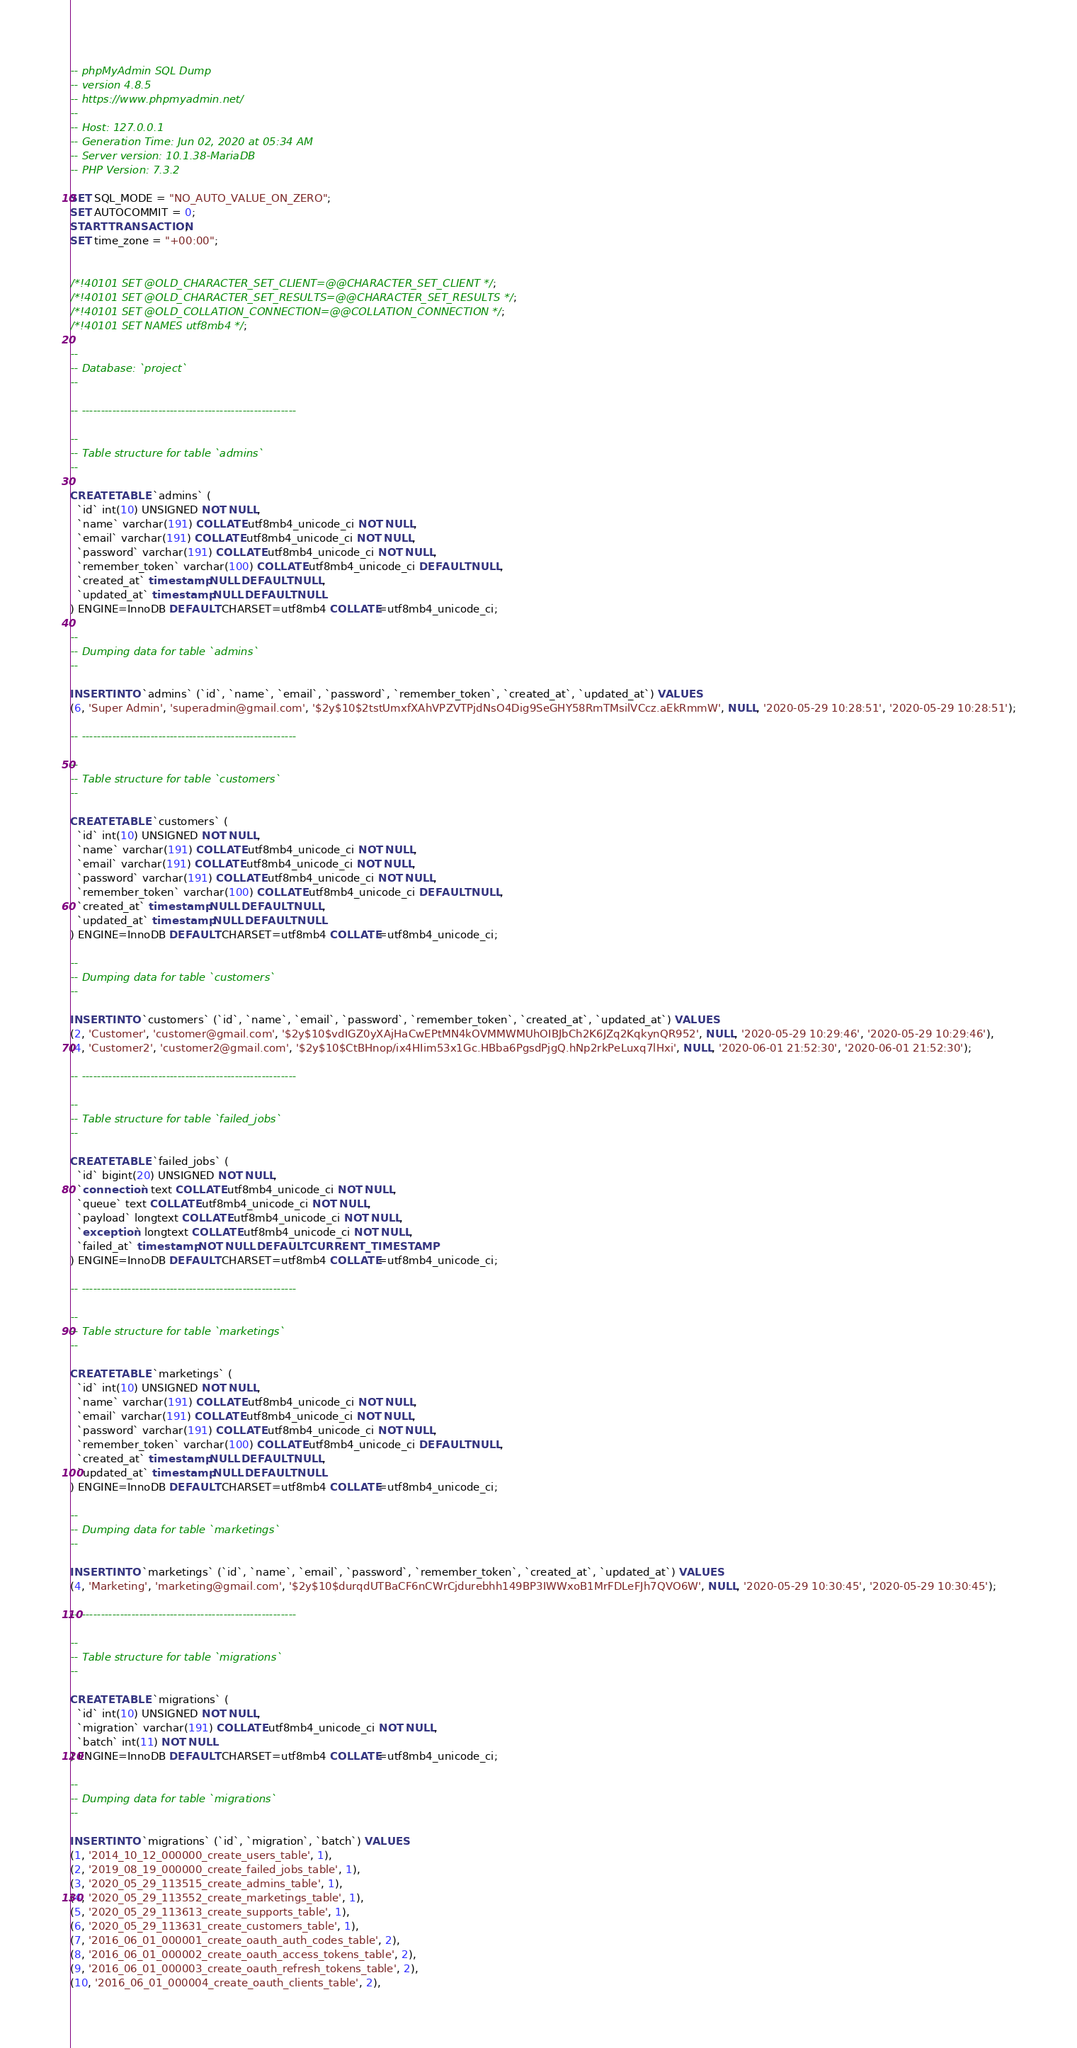<code> <loc_0><loc_0><loc_500><loc_500><_SQL_>-- phpMyAdmin SQL Dump
-- version 4.8.5
-- https://www.phpmyadmin.net/
--
-- Host: 127.0.0.1
-- Generation Time: Jun 02, 2020 at 05:34 AM
-- Server version: 10.1.38-MariaDB
-- PHP Version: 7.3.2

SET SQL_MODE = "NO_AUTO_VALUE_ON_ZERO";
SET AUTOCOMMIT = 0;
START TRANSACTION;
SET time_zone = "+00:00";


/*!40101 SET @OLD_CHARACTER_SET_CLIENT=@@CHARACTER_SET_CLIENT */;
/*!40101 SET @OLD_CHARACTER_SET_RESULTS=@@CHARACTER_SET_RESULTS */;
/*!40101 SET @OLD_COLLATION_CONNECTION=@@COLLATION_CONNECTION */;
/*!40101 SET NAMES utf8mb4 */;

--
-- Database: `project`
--

-- --------------------------------------------------------

--
-- Table structure for table `admins`
--

CREATE TABLE `admins` (
  `id` int(10) UNSIGNED NOT NULL,
  `name` varchar(191) COLLATE utf8mb4_unicode_ci NOT NULL,
  `email` varchar(191) COLLATE utf8mb4_unicode_ci NOT NULL,
  `password` varchar(191) COLLATE utf8mb4_unicode_ci NOT NULL,
  `remember_token` varchar(100) COLLATE utf8mb4_unicode_ci DEFAULT NULL,
  `created_at` timestamp NULL DEFAULT NULL,
  `updated_at` timestamp NULL DEFAULT NULL
) ENGINE=InnoDB DEFAULT CHARSET=utf8mb4 COLLATE=utf8mb4_unicode_ci;

--
-- Dumping data for table `admins`
--

INSERT INTO `admins` (`id`, `name`, `email`, `password`, `remember_token`, `created_at`, `updated_at`) VALUES
(6, 'Super Admin', 'superadmin@gmail.com', '$2y$10$2tstUmxfXAhVPZVTPjdNsO4Dig9SeGHY58RmTMsilVCcz.aEkRmmW', NULL, '2020-05-29 10:28:51', '2020-05-29 10:28:51');

-- --------------------------------------------------------

--
-- Table structure for table `customers`
--

CREATE TABLE `customers` (
  `id` int(10) UNSIGNED NOT NULL,
  `name` varchar(191) COLLATE utf8mb4_unicode_ci NOT NULL,
  `email` varchar(191) COLLATE utf8mb4_unicode_ci NOT NULL,
  `password` varchar(191) COLLATE utf8mb4_unicode_ci NOT NULL,
  `remember_token` varchar(100) COLLATE utf8mb4_unicode_ci DEFAULT NULL,
  `created_at` timestamp NULL DEFAULT NULL,
  `updated_at` timestamp NULL DEFAULT NULL
) ENGINE=InnoDB DEFAULT CHARSET=utf8mb4 COLLATE=utf8mb4_unicode_ci;

--
-- Dumping data for table `customers`
--

INSERT INTO `customers` (`id`, `name`, `email`, `password`, `remember_token`, `created_at`, `updated_at`) VALUES
(2, 'Customer', 'customer@gmail.com', '$2y$10$vdIGZ0yXAjHaCwEPtMN4kOVMMWMUhOIBJbCh2K6JZq2KqkynQR952', NULL, '2020-05-29 10:29:46', '2020-05-29 10:29:46'),
(4, 'Customer2', 'customer2@gmail.com', '$2y$10$CtBHnop/ix4HIim53x1Gc.HBba6PgsdPjgQ.hNp2rkPeLuxq7lHxi', NULL, '2020-06-01 21:52:30', '2020-06-01 21:52:30');

-- --------------------------------------------------------

--
-- Table structure for table `failed_jobs`
--

CREATE TABLE `failed_jobs` (
  `id` bigint(20) UNSIGNED NOT NULL,
  `connection` text COLLATE utf8mb4_unicode_ci NOT NULL,
  `queue` text COLLATE utf8mb4_unicode_ci NOT NULL,
  `payload` longtext COLLATE utf8mb4_unicode_ci NOT NULL,
  `exception` longtext COLLATE utf8mb4_unicode_ci NOT NULL,
  `failed_at` timestamp NOT NULL DEFAULT CURRENT_TIMESTAMP
) ENGINE=InnoDB DEFAULT CHARSET=utf8mb4 COLLATE=utf8mb4_unicode_ci;

-- --------------------------------------------------------

--
-- Table structure for table `marketings`
--

CREATE TABLE `marketings` (
  `id` int(10) UNSIGNED NOT NULL,
  `name` varchar(191) COLLATE utf8mb4_unicode_ci NOT NULL,
  `email` varchar(191) COLLATE utf8mb4_unicode_ci NOT NULL,
  `password` varchar(191) COLLATE utf8mb4_unicode_ci NOT NULL,
  `remember_token` varchar(100) COLLATE utf8mb4_unicode_ci DEFAULT NULL,
  `created_at` timestamp NULL DEFAULT NULL,
  `updated_at` timestamp NULL DEFAULT NULL
) ENGINE=InnoDB DEFAULT CHARSET=utf8mb4 COLLATE=utf8mb4_unicode_ci;

--
-- Dumping data for table `marketings`
--

INSERT INTO `marketings` (`id`, `name`, `email`, `password`, `remember_token`, `created_at`, `updated_at`) VALUES
(4, 'Marketing', 'marketing@gmail.com', '$2y$10$durqdUTBaCF6nCWrCjdurebhh149BP3IWWxoB1MrFDLeFJh7QVO6W', NULL, '2020-05-29 10:30:45', '2020-05-29 10:30:45');

-- --------------------------------------------------------

--
-- Table structure for table `migrations`
--

CREATE TABLE `migrations` (
  `id` int(10) UNSIGNED NOT NULL,
  `migration` varchar(191) COLLATE utf8mb4_unicode_ci NOT NULL,
  `batch` int(11) NOT NULL
) ENGINE=InnoDB DEFAULT CHARSET=utf8mb4 COLLATE=utf8mb4_unicode_ci;

--
-- Dumping data for table `migrations`
--

INSERT INTO `migrations` (`id`, `migration`, `batch`) VALUES
(1, '2014_10_12_000000_create_users_table', 1),
(2, '2019_08_19_000000_create_failed_jobs_table', 1),
(3, '2020_05_29_113515_create_admins_table', 1),
(4, '2020_05_29_113552_create_marketings_table', 1),
(5, '2020_05_29_113613_create_supports_table', 1),
(6, '2020_05_29_113631_create_customers_table', 1),
(7, '2016_06_01_000001_create_oauth_auth_codes_table', 2),
(8, '2016_06_01_000002_create_oauth_access_tokens_table', 2),
(9, '2016_06_01_000003_create_oauth_refresh_tokens_table', 2),
(10, '2016_06_01_000004_create_oauth_clients_table', 2),</code> 